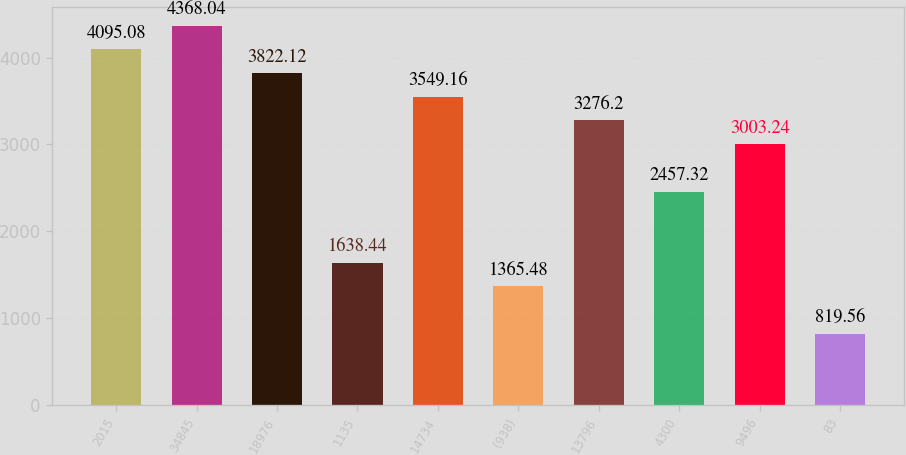<chart> <loc_0><loc_0><loc_500><loc_500><bar_chart><fcel>2015<fcel>34845<fcel>18976<fcel>1135<fcel>14734<fcel>(938)<fcel>13796<fcel>4300<fcel>9496<fcel>83<nl><fcel>4095.08<fcel>4368.04<fcel>3822.12<fcel>1638.44<fcel>3549.16<fcel>1365.48<fcel>3276.2<fcel>2457.32<fcel>3003.24<fcel>819.56<nl></chart> 